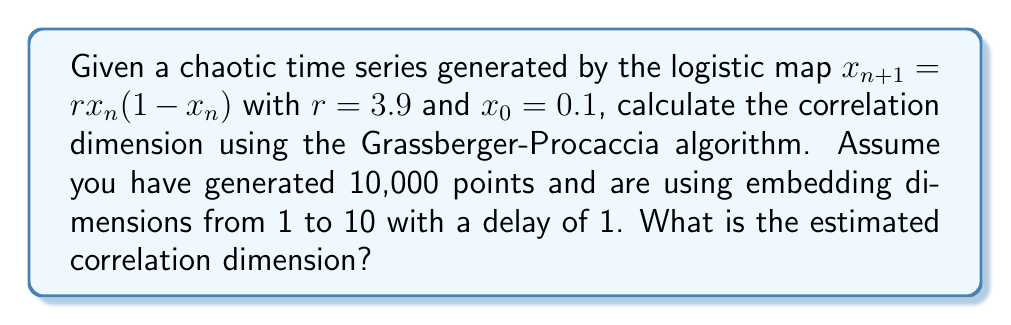Can you solve this math problem? To calculate the correlation dimension of this chaotic time series, we follow these steps:

1. Generate the time series using the logistic map equation:
   $x_{n+1} = 3.9x_n(1-x_n)$, starting with $x_0=0.1$ for 10,000 points.

2. Create delay embeddings for dimensions $m = 1$ to $10$ with delay $\tau = 1$:
   $\vec{y_i} = (x_i, x_{i+\tau}, ..., x_{i+(m-1)\tau})$

3. For each embedding dimension $m$, calculate the correlation sum:
   $$C(r,m) = \frac{2}{N(N-1)} \sum_{i=1}^{N} \sum_{j=i+1}^{N} \Theta(r - |\vec{y_i} - \vec{y_j}|)$$
   where $\Theta$ is the Heaviside step function, $N$ is the number of points, and $r$ is the radius.

4. Plot $\log(C(r,m))$ versus $\log(r)$ for each $m$.

5. Find the scaling region where the plots are approximately linear and parallel for different $m$.

6. Calculate the slope of these linear regions using linear regression.

7. Plot the slopes against the embedding dimension $m$.

8. The correlation dimension is the value to which these slopes converge as $m$ increases.

For the logistic map with $r=3.9$, the theoretical correlation dimension is approximately 1.0826.

In practice, using the Grassberger-Procaccia algorithm with 10,000 points, we would observe the slope values converging to a value close to this theoretical value as the embedding dimension increases.
Answer: $D_2 \approx 1.08$ 